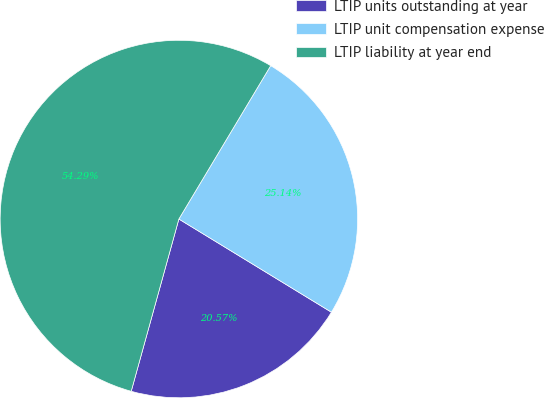Convert chart. <chart><loc_0><loc_0><loc_500><loc_500><pie_chart><fcel>LTIP units outstanding at year<fcel>LTIP unit compensation expense<fcel>LTIP liability at year end<nl><fcel>20.57%<fcel>25.14%<fcel>54.29%<nl></chart> 